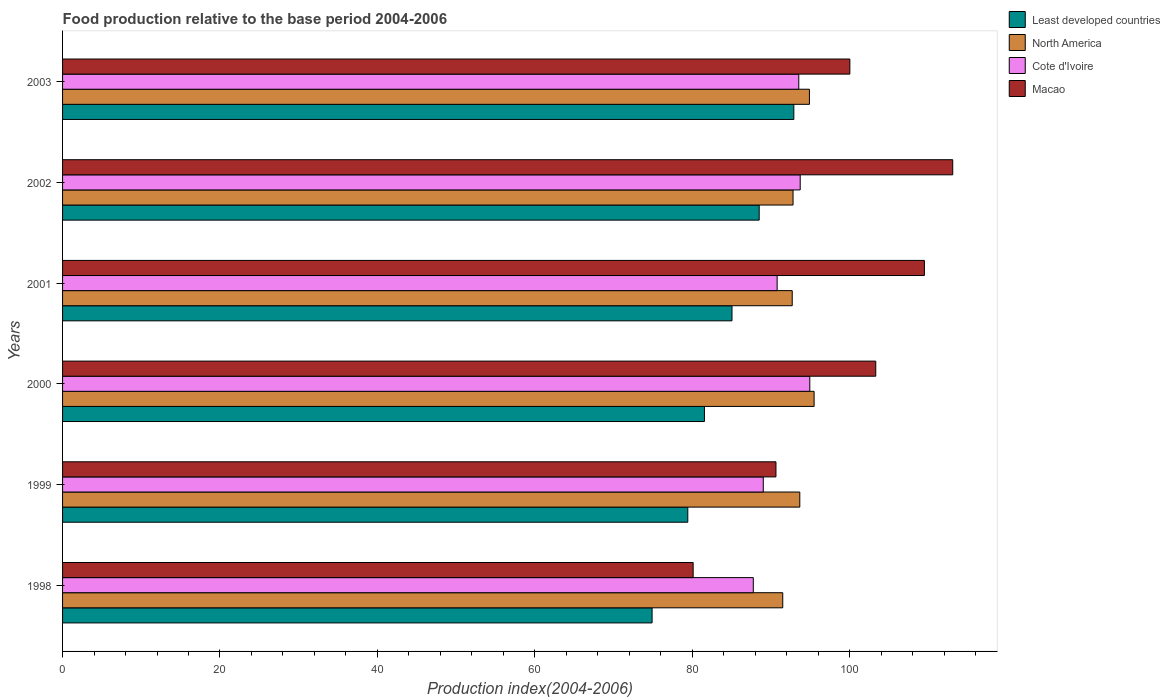How many groups of bars are there?
Make the answer very short. 6. Are the number of bars on each tick of the Y-axis equal?
Keep it short and to the point. Yes. How many bars are there on the 3rd tick from the bottom?
Offer a very short reply. 4. What is the label of the 3rd group of bars from the top?
Offer a terse response. 2001. What is the food production index in North America in 2001?
Give a very brief answer. 92.71. Across all years, what is the maximum food production index in Cote d'Ivoire?
Offer a very short reply. 94.94. Across all years, what is the minimum food production index in Macao?
Offer a terse response. 80.12. What is the total food production index in North America in the graph?
Offer a terse response. 561.07. What is the difference between the food production index in Cote d'Ivoire in 2000 and that in 2002?
Keep it short and to the point. 1.22. What is the difference between the food production index in Least developed countries in 1998 and the food production index in Cote d'Ivoire in 1999?
Your answer should be very brief. -14.13. What is the average food production index in Macao per year?
Give a very brief answer. 99.45. In the year 2000, what is the difference between the food production index in North America and food production index in Macao?
Your answer should be compact. -7.83. What is the ratio of the food production index in North America in 2001 to that in 2003?
Your response must be concise. 0.98. What is the difference between the highest and the second highest food production index in Macao?
Your answer should be compact. 3.6. What is the difference between the highest and the lowest food production index in North America?
Offer a very short reply. 3.98. Is it the case that in every year, the sum of the food production index in Macao and food production index in North America is greater than the sum of food production index in Least developed countries and food production index in Cote d'Ivoire?
Give a very brief answer. No. What does the 4th bar from the top in 1999 represents?
Ensure brevity in your answer.  Least developed countries. What does the 4th bar from the bottom in 2001 represents?
Your answer should be compact. Macao. Are all the bars in the graph horizontal?
Provide a short and direct response. Yes. Does the graph contain any zero values?
Offer a terse response. No. Does the graph contain grids?
Keep it short and to the point. No. Where does the legend appear in the graph?
Offer a very short reply. Top right. How are the legend labels stacked?
Offer a terse response. Vertical. What is the title of the graph?
Your response must be concise. Food production relative to the base period 2004-2006. What is the label or title of the X-axis?
Provide a succinct answer. Production index(2004-2006). What is the Production index(2004-2006) in Least developed countries in 1998?
Provide a succinct answer. 74.9. What is the Production index(2004-2006) of North America in 1998?
Offer a very short reply. 91.5. What is the Production index(2004-2006) of Cote d'Ivoire in 1998?
Offer a very short reply. 87.76. What is the Production index(2004-2006) of Macao in 1998?
Make the answer very short. 80.12. What is the Production index(2004-2006) in Least developed countries in 1999?
Provide a short and direct response. 79.44. What is the Production index(2004-2006) in North America in 1999?
Ensure brevity in your answer.  93.67. What is the Production index(2004-2006) in Cote d'Ivoire in 1999?
Give a very brief answer. 89.03. What is the Production index(2004-2006) of Macao in 1999?
Provide a succinct answer. 90.64. What is the Production index(2004-2006) in Least developed countries in 2000?
Your response must be concise. 81.55. What is the Production index(2004-2006) in North America in 2000?
Your response must be concise. 95.49. What is the Production index(2004-2006) in Cote d'Ivoire in 2000?
Provide a succinct answer. 94.94. What is the Production index(2004-2006) in Macao in 2000?
Provide a short and direct response. 103.32. What is the Production index(2004-2006) of Least developed countries in 2001?
Your answer should be compact. 85.05. What is the Production index(2004-2006) of North America in 2001?
Your answer should be compact. 92.71. What is the Production index(2004-2006) in Cote d'Ivoire in 2001?
Give a very brief answer. 90.79. What is the Production index(2004-2006) in Macao in 2001?
Make the answer very short. 109.5. What is the Production index(2004-2006) of Least developed countries in 2002?
Provide a short and direct response. 88.51. What is the Production index(2004-2006) of North America in 2002?
Provide a short and direct response. 92.81. What is the Production index(2004-2006) in Cote d'Ivoire in 2002?
Ensure brevity in your answer.  93.72. What is the Production index(2004-2006) of Macao in 2002?
Ensure brevity in your answer.  113.1. What is the Production index(2004-2006) of Least developed countries in 2003?
Give a very brief answer. 92.91. What is the Production index(2004-2006) in North America in 2003?
Make the answer very short. 94.89. What is the Production index(2004-2006) in Cote d'Ivoire in 2003?
Your answer should be very brief. 93.54. What is the Production index(2004-2006) of Macao in 2003?
Keep it short and to the point. 100.03. Across all years, what is the maximum Production index(2004-2006) in Least developed countries?
Ensure brevity in your answer.  92.91. Across all years, what is the maximum Production index(2004-2006) of North America?
Your response must be concise. 95.49. Across all years, what is the maximum Production index(2004-2006) in Cote d'Ivoire?
Offer a terse response. 94.94. Across all years, what is the maximum Production index(2004-2006) of Macao?
Ensure brevity in your answer.  113.1. Across all years, what is the minimum Production index(2004-2006) of Least developed countries?
Ensure brevity in your answer.  74.9. Across all years, what is the minimum Production index(2004-2006) in North America?
Offer a terse response. 91.5. Across all years, what is the minimum Production index(2004-2006) of Cote d'Ivoire?
Offer a very short reply. 87.76. Across all years, what is the minimum Production index(2004-2006) of Macao?
Your answer should be compact. 80.12. What is the total Production index(2004-2006) in Least developed countries in the graph?
Provide a short and direct response. 502.37. What is the total Production index(2004-2006) in North America in the graph?
Your answer should be compact. 561.07. What is the total Production index(2004-2006) in Cote d'Ivoire in the graph?
Provide a short and direct response. 549.78. What is the total Production index(2004-2006) in Macao in the graph?
Your response must be concise. 596.71. What is the difference between the Production index(2004-2006) of Least developed countries in 1998 and that in 1999?
Keep it short and to the point. -4.54. What is the difference between the Production index(2004-2006) of North America in 1998 and that in 1999?
Offer a terse response. -2.17. What is the difference between the Production index(2004-2006) of Cote d'Ivoire in 1998 and that in 1999?
Ensure brevity in your answer.  -1.27. What is the difference between the Production index(2004-2006) of Macao in 1998 and that in 1999?
Your answer should be compact. -10.52. What is the difference between the Production index(2004-2006) in Least developed countries in 1998 and that in 2000?
Offer a terse response. -6.65. What is the difference between the Production index(2004-2006) of North America in 1998 and that in 2000?
Give a very brief answer. -3.98. What is the difference between the Production index(2004-2006) of Cote d'Ivoire in 1998 and that in 2000?
Keep it short and to the point. -7.18. What is the difference between the Production index(2004-2006) of Macao in 1998 and that in 2000?
Your answer should be compact. -23.2. What is the difference between the Production index(2004-2006) in Least developed countries in 1998 and that in 2001?
Keep it short and to the point. -10.15. What is the difference between the Production index(2004-2006) of North America in 1998 and that in 2001?
Offer a very short reply. -1.2. What is the difference between the Production index(2004-2006) in Cote d'Ivoire in 1998 and that in 2001?
Your response must be concise. -3.03. What is the difference between the Production index(2004-2006) of Macao in 1998 and that in 2001?
Your answer should be very brief. -29.38. What is the difference between the Production index(2004-2006) in Least developed countries in 1998 and that in 2002?
Your answer should be compact. -13.61. What is the difference between the Production index(2004-2006) of North America in 1998 and that in 2002?
Your answer should be compact. -1.31. What is the difference between the Production index(2004-2006) in Cote d'Ivoire in 1998 and that in 2002?
Give a very brief answer. -5.96. What is the difference between the Production index(2004-2006) in Macao in 1998 and that in 2002?
Ensure brevity in your answer.  -32.98. What is the difference between the Production index(2004-2006) in Least developed countries in 1998 and that in 2003?
Your response must be concise. -18.01. What is the difference between the Production index(2004-2006) of North America in 1998 and that in 2003?
Your answer should be very brief. -3.39. What is the difference between the Production index(2004-2006) of Cote d'Ivoire in 1998 and that in 2003?
Provide a short and direct response. -5.78. What is the difference between the Production index(2004-2006) of Macao in 1998 and that in 2003?
Your response must be concise. -19.91. What is the difference between the Production index(2004-2006) in Least developed countries in 1999 and that in 2000?
Your response must be concise. -2.11. What is the difference between the Production index(2004-2006) of North America in 1999 and that in 2000?
Your response must be concise. -1.82. What is the difference between the Production index(2004-2006) in Cote d'Ivoire in 1999 and that in 2000?
Give a very brief answer. -5.91. What is the difference between the Production index(2004-2006) in Macao in 1999 and that in 2000?
Provide a short and direct response. -12.68. What is the difference between the Production index(2004-2006) of Least developed countries in 1999 and that in 2001?
Your answer should be compact. -5.62. What is the difference between the Production index(2004-2006) in North America in 1999 and that in 2001?
Make the answer very short. 0.96. What is the difference between the Production index(2004-2006) in Cote d'Ivoire in 1999 and that in 2001?
Your answer should be very brief. -1.76. What is the difference between the Production index(2004-2006) in Macao in 1999 and that in 2001?
Provide a short and direct response. -18.86. What is the difference between the Production index(2004-2006) of Least developed countries in 1999 and that in 2002?
Offer a terse response. -9.07. What is the difference between the Production index(2004-2006) in North America in 1999 and that in 2002?
Provide a short and direct response. 0.86. What is the difference between the Production index(2004-2006) in Cote d'Ivoire in 1999 and that in 2002?
Make the answer very short. -4.69. What is the difference between the Production index(2004-2006) in Macao in 1999 and that in 2002?
Ensure brevity in your answer.  -22.46. What is the difference between the Production index(2004-2006) of Least developed countries in 1999 and that in 2003?
Offer a terse response. -13.47. What is the difference between the Production index(2004-2006) in North America in 1999 and that in 2003?
Your answer should be very brief. -1.22. What is the difference between the Production index(2004-2006) in Cote d'Ivoire in 1999 and that in 2003?
Provide a short and direct response. -4.51. What is the difference between the Production index(2004-2006) in Macao in 1999 and that in 2003?
Your answer should be compact. -9.39. What is the difference between the Production index(2004-2006) of Least developed countries in 2000 and that in 2001?
Offer a terse response. -3.5. What is the difference between the Production index(2004-2006) in North America in 2000 and that in 2001?
Provide a short and direct response. 2.78. What is the difference between the Production index(2004-2006) in Cote d'Ivoire in 2000 and that in 2001?
Make the answer very short. 4.15. What is the difference between the Production index(2004-2006) in Macao in 2000 and that in 2001?
Provide a short and direct response. -6.18. What is the difference between the Production index(2004-2006) in Least developed countries in 2000 and that in 2002?
Ensure brevity in your answer.  -6.96. What is the difference between the Production index(2004-2006) in North America in 2000 and that in 2002?
Make the answer very short. 2.68. What is the difference between the Production index(2004-2006) of Cote d'Ivoire in 2000 and that in 2002?
Ensure brevity in your answer.  1.22. What is the difference between the Production index(2004-2006) in Macao in 2000 and that in 2002?
Provide a succinct answer. -9.78. What is the difference between the Production index(2004-2006) of Least developed countries in 2000 and that in 2003?
Give a very brief answer. -11.36. What is the difference between the Production index(2004-2006) of North America in 2000 and that in 2003?
Your answer should be compact. 0.59. What is the difference between the Production index(2004-2006) in Macao in 2000 and that in 2003?
Provide a succinct answer. 3.29. What is the difference between the Production index(2004-2006) in Least developed countries in 2001 and that in 2002?
Offer a very short reply. -3.46. What is the difference between the Production index(2004-2006) in North America in 2001 and that in 2002?
Provide a succinct answer. -0.11. What is the difference between the Production index(2004-2006) of Cote d'Ivoire in 2001 and that in 2002?
Ensure brevity in your answer.  -2.93. What is the difference between the Production index(2004-2006) in Least developed countries in 2001 and that in 2003?
Provide a short and direct response. -7.86. What is the difference between the Production index(2004-2006) of North America in 2001 and that in 2003?
Keep it short and to the point. -2.19. What is the difference between the Production index(2004-2006) in Cote d'Ivoire in 2001 and that in 2003?
Give a very brief answer. -2.75. What is the difference between the Production index(2004-2006) in Macao in 2001 and that in 2003?
Offer a terse response. 9.47. What is the difference between the Production index(2004-2006) in Least developed countries in 2002 and that in 2003?
Your answer should be very brief. -4.4. What is the difference between the Production index(2004-2006) of North America in 2002 and that in 2003?
Provide a succinct answer. -2.08. What is the difference between the Production index(2004-2006) in Cote d'Ivoire in 2002 and that in 2003?
Your answer should be compact. 0.18. What is the difference between the Production index(2004-2006) of Macao in 2002 and that in 2003?
Provide a short and direct response. 13.07. What is the difference between the Production index(2004-2006) of Least developed countries in 1998 and the Production index(2004-2006) of North America in 1999?
Provide a short and direct response. -18.77. What is the difference between the Production index(2004-2006) in Least developed countries in 1998 and the Production index(2004-2006) in Cote d'Ivoire in 1999?
Offer a terse response. -14.13. What is the difference between the Production index(2004-2006) in Least developed countries in 1998 and the Production index(2004-2006) in Macao in 1999?
Your answer should be compact. -15.74. What is the difference between the Production index(2004-2006) in North America in 1998 and the Production index(2004-2006) in Cote d'Ivoire in 1999?
Give a very brief answer. 2.47. What is the difference between the Production index(2004-2006) in North America in 1998 and the Production index(2004-2006) in Macao in 1999?
Provide a succinct answer. 0.86. What is the difference between the Production index(2004-2006) of Cote d'Ivoire in 1998 and the Production index(2004-2006) of Macao in 1999?
Ensure brevity in your answer.  -2.88. What is the difference between the Production index(2004-2006) of Least developed countries in 1998 and the Production index(2004-2006) of North America in 2000?
Your answer should be very brief. -20.58. What is the difference between the Production index(2004-2006) in Least developed countries in 1998 and the Production index(2004-2006) in Cote d'Ivoire in 2000?
Provide a short and direct response. -20.04. What is the difference between the Production index(2004-2006) in Least developed countries in 1998 and the Production index(2004-2006) in Macao in 2000?
Provide a succinct answer. -28.42. What is the difference between the Production index(2004-2006) in North America in 1998 and the Production index(2004-2006) in Cote d'Ivoire in 2000?
Offer a very short reply. -3.44. What is the difference between the Production index(2004-2006) in North America in 1998 and the Production index(2004-2006) in Macao in 2000?
Make the answer very short. -11.82. What is the difference between the Production index(2004-2006) of Cote d'Ivoire in 1998 and the Production index(2004-2006) of Macao in 2000?
Give a very brief answer. -15.56. What is the difference between the Production index(2004-2006) of Least developed countries in 1998 and the Production index(2004-2006) of North America in 2001?
Your answer should be compact. -17.8. What is the difference between the Production index(2004-2006) of Least developed countries in 1998 and the Production index(2004-2006) of Cote d'Ivoire in 2001?
Your answer should be very brief. -15.89. What is the difference between the Production index(2004-2006) in Least developed countries in 1998 and the Production index(2004-2006) in Macao in 2001?
Offer a terse response. -34.6. What is the difference between the Production index(2004-2006) in North America in 1998 and the Production index(2004-2006) in Cote d'Ivoire in 2001?
Ensure brevity in your answer.  0.71. What is the difference between the Production index(2004-2006) of North America in 1998 and the Production index(2004-2006) of Macao in 2001?
Your answer should be compact. -18. What is the difference between the Production index(2004-2006) in Cote d'Ivoire in 1998 and the Production index(2004-2006) in Macao in 2001?
Offer a terse response. -21.74. What is the difference between the Production index(2004-2006) in Least developed countries in 1998 and the Production index(2004-2006) in North America in 2002?
Provide a succinct answer. -17.91. What is the difference between the Production index(2004-2006) in Least developed countries in 1998 and the Production index(2004-2006) in Cote d'Ivoire in 2002?
Your answer should be compact. -18.82. What is the difference between the Production index(2004-2006) in Least developed countries in 1998 and the Production index(2004-2006) in Macao in 2002?
Ensure brevity in your answer.  -38.2. What is the difference between the Production index(2004-2006) of North America in 1998 and the Production index(2004-2006) of Cote d'Ivoire in 2002?
Offer a terse response. -2.22. What is the difference between the Production index(2004-2006) of North America in 1998 and the Production index(2004-2006) of Macao in 2002?
Keep it short and to the point. -21.6. What is the difference between the Production index(2004-2006) in Cote d'Ivoire in 1998 and the Production index(2004-2006) in Macao in 2002?
Keep it short and to the point. -25.34. What is the difference between the Production index(2004-2006) of Least developed countries in 1998 and the Production index(2004-2006) of North America in 2003?
Make the answer very short. -19.99. What is the difference between the Production index(2004-2006) in Least developed countries in 1998 and the Production index(2004-2006) in Cote d'Ivoire in 2003?
Your response must be concise. -18.64. What is the difference between the Production index(2004-2006) of Least developed countries in 1998 and the Production index(2004-2006) of Macao in 2003?
Give a very brief answer. -25.13. What is the difference between the Production index(2004-2006) of North America in 1998 and the Production index(2004-2006) of Cote d'Ivoire in 2003?
Give a very brief answer. -2.04. What is the difference between the Production index(2004-2006) of North America in 1998 and the Production index(2004-2006) of Macao in 2003?
Your answer should be compact. -8.53. What is the difference between the Production index(2004-2006) in Cote d'Ivoire in 1998 and the Production index(2004-2006) in Macao in 2003?
Your answer should be very brief. -12.27. What is the difference between the Production index(2004-2006) in Least developed countries in 1999 and the Production index(2004-2006) in North America in 2000?
Offer a terse response. -16.05. What is the difference between the Production index(2004-2006) in Least developed countries in 1999 and the Production index(2004-2006) in Cote d'Ivoire in 2000?
Your answer should be very brief. -15.5. What is the difference between the Production index(2004-2006) of Least developed countries in 1999 and the Production index(2004-2006) of Macao in 2000?
Keep it short and to the point. -23.88. What is the difference between the Production index(2004-2006) in North America in 1999 and the Production index(2004-2006) in Cote d'Ivoire in 2000?
Ensure brevity in your answer.  -1.27. What is the difference between the Production index(2004-2006) of North America in 1999 and the Production index(2004-2006) of Macao in 2000?
Make the answer very short. -9.65. What is the difference between the Production index(2004-2006) in Cote d'Ivoire in 1999 and the Production index(2004-2006) in Macao in 2000?
Ensure brevity in your answer.  -14.29. What is the difference between the Production index(2004-2006) in Least developed countries in 1999 and the Production index(2004-2006) in North America in 2001?
Your response must be concise. -13.27. What is the difference between the Production index(2004-2006) in Least developed countries in 1999 and the Production index(2004-2006) in Cote d'Ivoire in 2001?
Provide a short and direct response. -11.35. What is the difference between the Production index(2004-2006) of Least developed countries in 1999 and the Production index(2004-2006) of Macao in 2001?
Offer a very short reply. -30.06. What is the difference between the Production index(2004-2006) of North America in 1999 and the Production index(2004-2006) of Cote d'Ivoire in 2001?
Offer a terse response. 2.88. What is the difference between the Production index(2004-2006) in North America in 1999 and the Production index(2004-2006) in Macao in 2001?
Provide a short and direct response. -15.83. What is the difference between the Production index(2004-2006) of Cote d'Ivoire in 1999 and the Production index(2004-2006) of Macao in 2001?
Provide a short and direct response. -20.47. What is the difference between the Production index(2004-2006) in Least developed countries in 1999 and the Production index(2004-2006) in North America in 2002?
Give a very brief answer. -13.37. What is the difference between the Production index(2004-2006) in Least developed countries in 1999 and the Production index(2004-2006) in Cote d'Ivoire in 2002?
Keep it short and to the point. -14.28. What is the difference between the Production index(2004-2006) of Least developed countries in 1999 and the Production index(2004-2006) of Macao in 2002?
Keep it short and to the point. -33.66. What is the difference between the Production index(2004-2006) in North America in 1999 and the Production index(2004-2006) in Cote d'Ivoire in 2002?
Keep it short and to the point. -0.05. What is the difference between the Production index(2004-2006) of North America in 1999 and the Production index(2004-2006) of Macao in 2002?
Give a very brief answer. -19.43. What is the difference between the Production index(2004-2006) in Cote d'Ivoire in 1999 and the Production index(2004-2006) in Macao in 2002?
Offer a very short reply. -24.07. What is the difference between the Production index(2004-2006) of Least developed countries in 1999 and the Production index(2004-2006) of North America in 2003?
Your response must be concise. -15.45. What is the difference between the Production index(2004-2006) in Least developed countries in 1999 and the Production index(2004-2006) in Cote d'Ivoire in 2003?
Provide a succinct answer. -14.1. What is the difference between the Production index(2004-2006) in Least developed countries in 1999 and the Production index(2004-2006) in Macao in 2003?
Your answer should be very brief. -20.59. What is the difference between the Production index(2004-2006) of North America in 1999 and the Production index(2004-2006) of Cote d'Ivoire in 2003?
Provide a succinct answer. 0.13. What is the difference between the Production index(2004-2006) in North America in 1999 and the Production index(2004-2006) in Macao in 2003?
Ensure brevity in your answer.  -6.36. What is the difference between the Production index(2004-2006) in Cote d'Ivoire in 1999 and the Production index(2004-2006) in Macao in 2003?
Provide a succinct answer. -11. What is the difference between the Production index(2004-2006) of Least developed countries in 2000 and the Production index(2004-2006) of North America in 2001?
Make the answer very short. -11.15. What is the difference between the Production index(2004-2006) in Least developed countries in 2000 and the Production index(2004-2006) in Cote d'Ivoire in 2001?
Provide a short and direct response. -9.24. What is the difference between the Production index(2004-2006) in Least developed countries in 2000 and the Production index(2004-2006) in Macao in 2001?
Your answer should be very brief. -27.95. What is the difference between the Production index(2004-2006) of North America in 2000 and the Production index(2004-2006) of Cote d'Ivoire in 2001?
Your answer should be compact. 4.7. What is the difference between the Production index(2004-2006) of North America in 2000 and the Production index(2004-2006) of Macao in 2001?
Offer a terse response. -14.01. What is the difference between the Production index(2004-2006) in Cote d'Ivoire in 2000 and the Production index(2004-2006) in Macao in 2001?
Keep it short and to the point. -14.56. What is the difference between the Production index(2004-2006) of Least developed countries in 2000 and the Production index(2004-2006) of North America in 2002?
Provide a short and direct response. -11.26. What is the difference between the Production index(2004-2006) of Least developed countries in 2000 and the Production index(2004-2006) of Cote d'Ivoire in 2002?
Ensure brevity in your answer.  -12.17. What is the difference between the Production index(2004-2006) in Least developed countries in 2000 and the Production index(2004-2006) in Macao in 2002?
Your answer should be compact. -31.55. What is the difference between the Production index(2004-2006) of North America in 2000 and the Production index(2004-2006) of Cote d'Ivoire in 2002?
Ensure brevity in your answer.  1.77. What is the difference between the Production index(2004-2006) of North America in 2000 and the Production index(2004-2006) of Macao in 2002?
Your response must be concise. -17.61. What is the difference between the Production index(2004-2006) in Cote d'Ivoire in 2000 and the Production index(2004-2006) in Macao in 2002?
Give a very brief answer. -18.16. What is the difference between the Production index(2004-2006) in Least developed countries in 2000 and the Production index(2004-2006) in North America in 2003?
Provide a short and direct response. -13.34. What is the difference between the Production index(2004-2006) of Least developed countries in 2000 and the Production index(2004-2006) of Cote d'Ivoire in 2003?
Provide a short and direct response. -11.99. What is the difference between the Production index(2004-2006) of Least developed countries in 2000 and the Production index(2004-2006) of Macao in 2003?
Provide a short and direct response. -18.48. What is the difference between the Production index(2004-2006) of North America in 2000 and the Production index(2004-2006) of Cote d'Ivoire in 2003?
Your response must be concise. 1.95. What is the difference between the Production index(2004-2006) in North America in 2000 and the Production index(2004-2006) in Macao in 2003?
Your answer should be compact. -4.54. What is the difference between the Production index(2004-2006) of Cote d'Ivoire in 2000 and the Production index(2004-2006) of Macao in 2003?
Offer a terse response. -5.09. What is the difference between the Production index(2004-2006) in Least developed countries in 2001 and the Production index(2004-2006) in North America in 2002?
Provide a short and direct response. -7.76. What is the difference between the Production index(2004-2006) of Least developed countries in 2001 and the Production index(2004-2006) of Cote d'Ivoire in 2002?
Ensure brevity in your answer.  -8.67. What is the difference between the Production index(2004-2006) in Least developed countries in 2001 and the Production index(2004-2006) in Macao in 2002?
Your response must be concise. -28.05. What is the difference between the Production index(2004-2006) of North America in 2001 and the Production index(2004-2006) of Cote d'Ivoire in 2002?
Your response must be concise. -1.01. What is the difference between the Production index(2004-2006) in North America in 2001 and the Production index(2004-2006) in Macao in 2002?
Ensure brevity in your answer.  -20.39. What is the difference between the Production index(2004-2006) in Cote d'Ivoire in 2001 and the Production index(2004-2006) in Macao in 2002?
Your response must be concise. -22.31. What is the difference between the Production index(2004-2006) of Least developed countries in 2001 and the Production index(2004-2006) of North America in 2003?
Keep it short and to the point. -9.84. What is the difference between the Production index(2004-2006) in Least developed countries in 2001 and the Production index(2004-2006) in Cote d'Ivoire in 2003?
Make the answer very short. -8.49. What is the difference between the Production index(2004-2006) in Least developed countries in 2001 and the Production index(2004-2006) in Macao in 2003?
Make the answer very short. -14.98. What is the difference between the Production index(2004-2006) in North America in 2001 and the Production index(2004-2006) in Cote d'Ivoire in 2003?
Provide a short and direct response. -0.83. What is the difference between the Production index(2004-2006) of North America in 2001 and the Production index(2004-2006) of Macao in 2003?
Your answer should be very brief. -7.32. What is the difference between the Production index(2004-2006) in Cote d'Ivoire in 2001 and the Production index(2004-2006) in Macao in 2003?
Ensure brevity in your answer.  -9.24. What is the difference between the Production index(2004-2006) in Least developed countries in 2002 and the Production index(2004-2006) in North America in 2003?
Make the answer very short. -6.38. What is the difference between the Production index(2004-2006) in Least developed countries in 2002 and the Production index(2004-2006) in Cote d'Ivoire in 2003?
Give a very brief answer. -5.03. What is the difference between the Production index(2004-2006) in Least developed countries in 2002 and the Production index(2004-2006) in Macao in 2003?
Give a very brief answer. -11.52. What is the difference between the Production index(2004-2006) of North America in 2002 and the Production index(2004-2006) of Cote d'Ivoire in 2003?
Provide a succinct answer. -0.73. What is the difference between the Production index(2004-2006) in North America in 2002 and the Production index(2004-2006) in Macao in 2003?
Give a very brief answer. -7.22. What is the difference between the Production index(2004-2006) of Cote d'Ivoire in 2002 and the Production index(2004-2006) of Macao in 2003?
Your answer should be compact. -6.31. What is the average Production index(2004-2006) in Least developed countries per year?
Make the answer very short. 83.73. What is the average Production index(2004-2006) of North America per year?
Provide a short and direct response. 93.51. What is the average Production index(2004-2006) of Cote d'Ivoire per year?
Your answer should be very brief. 91.63. What is the average Production index(2004-2006) of Macao per year?
Your answer should be very brief. 99.45. In the year 1998, what is the difference between the Production index(2004-2006) in Least developed countries and Production index(2004-2006) in North America?
Your answer should be very brief. -16.6. In the year 1998, what is the difference between the Production index(2004-2006) in Least developed countries and Production index(2004-2006) in Cote d'Ivoire?
Provide a short and direct response. -12.86. In the year 1998, what is the difference between the Production index(2004-2006) of Least developed countries and Production index(2004-2006) of Macao?
Give a very brief answer. -5.22. In the year 1998, what is the difference between the Production index(2004-2006) in North America and Production index(2004-2006) in Cote d'Ivoire?
Offer a very short reply. 3.74. In the year 1998, what is the difference between the Production index(2004-2006) in North America and Production index(2004-2006) in Macao?
Keep it short and to the point. 11.38. In the year 1998, what is the difference between the Production index(2004-2006) of Cote d'Ivoire and Production index(2004-2006) of Macao?
Keep it short and to the point. 7.64. In the year 1999, what is the difference between the Production index(2004-2006) in Least developed countries and Production index(2004-2006) in North America?
Your answer should be compact. -14.23. In the year 1999, what is the difference between the Production index(2004-2006) of Least developed countries and Production index(2004-2006) of Cote d'Ivoire?
Your answer should be very brief. -9.59. In the year 1999, what is the difference between the Production index(2004-2006) of Least developed countries and Production index(2004-2006) of Macao?
Offer a very short reply. -11.2. In the year 1999, what is the difference between the Production index(2004-2006) of North America and Production index(2004-2006) of Cote d'Ivoire?
Your answer should be compact. 4.64. In the year 1999, what is the difference between the Production index(2004-2006) of North America and Production index(2004-2006) of Macao?
Your response must be concise. 3.03. In the year 1999, what is the difference between the Production index(2004-2006) of Cote d'Ivoire and Production index(2004-2006) of Macao?
Your response must be concise. -1.61. In the year 2000, what is the difference between the Production index(2004-2006) of Least developed countries and Production index(2004-2006) of North America?
Offer a very short reply. -13.94. In the year 2000, what is the difference between the Production index(2004-2006) in Least developed countries and Production index(2004-2006) in Cote d'Ivoire?
Make the answer very short. -13.39. In the year 2000, what is the difference between the Production index(2004-2006) in Least developed countries and Production index(2004-2006) in Macao?
Provide a succinct answer. -21.77. In the year 2000, what is the difference between the Production index(2004-2006) in North America and Production index(2004-2006) in Cote d'Ivoire?
Provide a succinct answer. 0.55. In the year 2000, what is the difference between the Production index(2004-2006) of North America and Production index(2004-2006) of Macao?
Offer a very short reply. -7.83. In the year 2000, what is the difference between the Production index(2004-2006) of Cote d'Ivoire and Production index(2004-2006) of Macao?
Your answer should be compact. -8.38. In the year 2001, what is the difference between the Production index(2004-2006) of Least developed countries and Production index(2004-2006) of North America?
Provide a succinct answer. -7.65. In the year 2001, what is the difference between the Production index(2004-2006) in Least developed countries and Production index(2004-2006) in Cote d'Ivoire?
Offer a very short reply. -5.74. In the year 2001, what is the difference between the Production index(2004-2006) of Least developed countries and Production index(2004-2006) of Macao?
Ensure brevity in your answer.  -24.45. In the year 2001, what is the difference between the Production index(2004-2006) in North America and Production index(2004-2006) in Cote d'Ivoire?
Offer a terse response. 1.92. In the year 2001, what is the difference between the Production index(2004-2006) in North America and Production index(2004-2006) in Macao?
Keep it short and to the point. -16.79. In the year 2001, what is the difference between the Production index(2004-2006) of Cote d'Ivoire and Production index(2004-2006) of Macao?
Your response must be concise. -18.71. In the year 2002, what is the difference between the Production index(2004-2006) of Least developed countries and Production index(2004-2006) of North America?
Your answer should be very brief. -4.3. In the year 2002, what is the difference between the Production index(2004-2006) of Least developed countries and Production index(2004-2006) of Cote d'Ivoire?
Offer a very short reply. -5.21. In the year 2002, what is the difference between the Production index(2004-2006) of Least developed countries and Production index(2004-2006) of Macao?
Give a very brief answer. -24.59. In the year 2002, what is the difference between the Production index(2004-2006) of North America and Production index(2004-2006) of Cote d'Ivoire?
Your answer should be compact. -0.91. In the year 2002, what is the difference between the Production index(2004-2006) of North America and Production index(2004-2006) of Macao?
Offer a terse response. -20.29. In the year 2002, what is the difference between the Production index(2004-2006) of Cote d'Ivoire and Production index(2004-2006) of Macao?
Keep it short and to the point. -19.38. In the year 2003, what is the difference between the Production index(2004-2006) in Least developed countries and Production index(2004-2006) in North America?
Your answer should be compact. -1.98. In the year 2003, what is the difference between the Production index(2004-2006) in Least developed countries and Production index(2004-2006) in Cote d'Ivoire?
Make the answer very short. -0.63. In the year 2003, what is the difference between the Production index(2004-2006) in Least developed countries and Production index(2004-2006) in Macao?
Offer a very short reply. -7.12. In the year 2003, what is the difference between the Production index(2004-2006) of North America and Production index(2004-2006) of Cote d'Ivoire?
Give a very brief answer. 1.35. In the year 2003, what is the difference between the Production index(2004-2006) of North America and Production index(2004-2006) of Macao?
Make the answer very short. -5.14. In the year 2003, what is the difference between the Production index(2004-2006) in Cote d'Ivoire and Production index(2004-2006) in Macao?
Your response must be concise. -6.49. What is the ratio of the Production index(2004-2006) of Least developed countries in 1998 to that in 1999?
Provide a succinct answer. 0.94. What is the ratio of the Production index(2004-2006) of North America in 1998 to that in 1999?
Provide a short and direct response. 0.98. What is the ratio of the Production index(2004-2006) of Cote d'Ivoire in 1998 to that in 1999?
Your answer should be very brief. 0.99. What is the ratio of the Production index(2004-2006) in Macao in 1998 to that in 1999?
Ensure brevity in your answer.  0.88. What is the ratio of the Production index(2004-2006) of Least developed countries in 1998 to that in 2000?
Provide a succinct answer. 0.92. What is the ratio of the Production index(2004-2006) in North America in 1998 to that in 2000?
Provide a succinct answer. 0.96. What is the ratio of the Production index(2004-2006) in Cote d'Ivoire in 1998 to that in 2000?
Provide a short and direct response. 0.92. What is the ratio of the Production index(2004-2006) of Macao in 1998 to that in 2000?
Your answer should be compact. 0.78. What is the ratio of the Production index(2004-2006) in Least developed countries in 1998 to that in 2001?
Make the answer very short. 0.88. What is the ratio of the Production index(2004-2006) in Cote d'Ivoire in 1998 to that in 2001?
Keep it short and to the point. 0.97. What is the ratio of the Production index(2004-2006) of Macao in 1998 to that in 2001?
Offer a terse response. 0.73. What is the ratio of the Production index(2004-2006) in Least developed countries in 1998 to that in 2002?
Provide a short and direct response. 0.85. What is the ratio of the Production index(2004-2006) of North America in 1998 to that in 2002?
Your response must be concise. 0.99. What is the ratio of the Production index(2004-2006) in Cote d'Ivoire in 1998 to that in 2002?
Ensure brevity in your answer.  0.94. What is the ratio of the Production index(2004-2006) in Macao in 1998 to that in 2002?
Keep it short and to the point. 0.71. What is the ratio of the Production index(2004-2006) in Least developed countries in 1998 to that in 2003?
Provide a short and direct response. 0.81. What is the ratio of the Production index(2004-2006) in North America in 1998 to that in 2003?
Your response must be concise. 0.96. What is the ratio of the Production index(2004-2006) of Cote d'Ivoire in 1998 to that in 2003?
Offer a very short reply. 0.94. What is the ratio of the Production index(2004-2006) in Macao in 1998 to that in 2003?
Your response must be concise. 0.8. What is the ratio of the Production index(2004-2006) of Least developed countries in 1999 to that in 2000?
Your answer should be very brief. 0.97. What is the ratio of the Production index(2004-2006) in North America in 1999 to that in 2000?
Provide a short and direct response. 0.98. What is the ratio of the Production index(2004-2006) in Cote d'Ivoire in 1999 to that in 2000?
Keep it short and to the point. 0.94. What is the ratio of the Production index(2004-2006) in Macao in 1999 to that in 2000?
Provide a short and direct response. 0.88. What is the ratio of the Production index(2004-2006) in Least developed countries in 1999 to that in 2001?
Provide a succinct answer. 0.93. What is the ratio of the Production index(2004-2006) in North America in 1999 to that in 2001?
Give a very brief answer. 1.01. What is the ratio of the Production index(2004-2006) in Cote d'Ivoire in 1999 to that in 2001?
Your answer should be compact. 0.98. What is the ratio of the Production index(2004-2006) of Macao in 1999 to that in 2001?
Provide a succinct answer. 0.83. What is the ratio of the Production index(2004-2006) of Least developed countries in 1999 to that in 2002?
Give a very brief answer. 0.9. What is the ratio of the Production index(2004-2006) in North America in 1999 to that in 2002?
Ensure brevity in your answer.  1.01. What is the ratio of the Production index(2004-2006) in Cote d'Ivoire in 1999 to that in 2002?
Provide a succinct answer. 0.95. What is the ratio of the Production index(2004-2006) of Macao in 1999 to that in 2002?
Make the answer very short. 0.8. What is the ratio of the Production index(2004-2006) of Least developed countries in 1999 to that in 2003?
Your response must be concise. 0.85. What is the ratio of the Production index(2004-2006) in North America in 1999 to that in 2003?
Make the answer very short. 0.99. What is the ratio of the Production index(2004-2006) of Cote d'Ivoire in 1999 to that in 2003?
Provide a short and direct response. 0.95. What is the ratio of the Production index(2004-2006) of Macao in 1999 to that in 2003?
Your answer should be compact. 0.91. What is the ratio of the Production index(2004-2006) of Least developed countries in 2000 to that in 2001?
Offer a very short reply. 0.96. What is the ratio of the Production index(2004-2006) in Cote d'Ivoire in 2000 to that in 2001?
Your answer should be compact. 1.05. What is the ratio of the Production index(2004-2006) of Macao in 2000 to that in 2001?
Provide a short and direct response. 0.94. What is the ratio of the Production index(2004-2006) in Least developed countries in 2000 to that in 2002?
Your answer should be compact. 0.92. What is the ratio of the Production index(2004-2006) of North America in 2000 to that in 2002?
Offer a very short reply. 1.03. What is the ratio of the Production index(2004-2006) in Macao in 2000 to that in 2002?
Your answer should be compact. 0.91. What is the ratio of the Production index(2004-2006) of Least developed countries in 2000 to that in 2003?
Your answer should be very brief. 0.88. What is the ratio of the Production index(2004-2006) of Macao in 2000 to that in 2003?
Make the answer very short. 1.03. What is the ratio of the Production index(2004-2006) of Least developed countries in 2001 to that in 2002?
Make the answer very short. 0.96. What is the ratio of the Production index(2004-2006) of North America in 2001 to that in 2002?
Your response must be concise. 1. What is the ratio of the Production index(2004-2006) of Cote d'Ivoire in 2001 to that in 2002?
Give a very brief answer. 0.97. What is the ratio of the Production index(2004-2006) of Macao in 2001 to that in 2002?
Your response must be concise. 0.97. What is the ratio of the Production index(2004-2006) of Least developed countries in 2001 to that in 2003?
Provide a short and direct response. 0.92. What is the ratio of the Production index(2004-2006) in North America in 2001 to that in 2003?
Offer a terse response. 0.98. What is the ratio of the Production index(2004-2006) in Cote d'Ivoire in 2001 to that in 2003?
Ensure brevity in your answer.  0.97. What is the ratio of the Production index(2004-2006) in Macao in 2001 to that in 2003?
Make the answer very short. 1.09. What is the ratio of the Production index(2004-2006) of Least developed countries in 2002 to that in 2003?
Provide a short and direct response. 0.95. What is the ratio of the Production index(2004-2006) of North America in 2002 to that in 2003?
Provide a succinct answer. 0.98. What is the ratio of the Production index(2004-2006) of Cote d'Ivoire in 2002 to that in 2003?
Your answer should be compact. 1. What is the ratio of the Production index(2004-2006) of Macao in 2002 to that in 2003?
Provide a short and direct response. 1.13. What is the difference between the highest and the second highest Production index(2004-2006) of Least developed countries?
Ensure brevity in your answer.  4.4. What is the difference between the highest and the second highest Production index(2004-2006) in North America?
Provide a short and direct response. 0.59. What is the difference between the highest and the second highest Production index(2004-2006) in Cote d'Ivoire?
Offer a terse response. 1.22. What is the difference between the highest and the lowest Production index(2004-2006) of Least developed countries?
Give a very brief answer. 18.01. What is the difference between the highest and the lowest Production index(2004-2006) in North America?
Keep it short and to the point. 3.98. What is the difference between the highest and the lowest Production index(2004-2006) in Cote d'Ivoire?
Provide a short and direct response. 7.18. What is the difference between the highest and the lowest Production index(2004-2006) in Macao?
Provide a succinct answer. 32.98. 